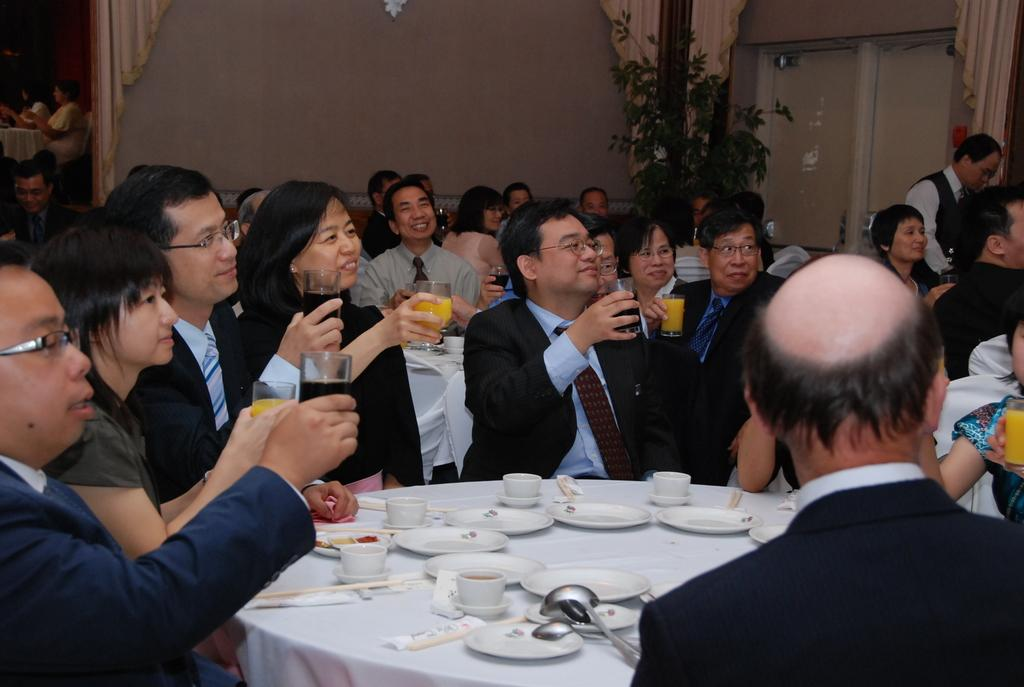How many people are in the image? There is a group of people in the image, but the exact number is not specified. What are the people doing in the image? The people are sitting around a table in the image. What are the people holding in their hands? The people are holding juice glasses in the image. What else can be seen on the table in the image? There are empty plates and coffee cups on the table in the image. Can you see any worms swimming in the juice glasses in the image? There are no worms or swimming activity visible in the image; the people are holding juice glasses. 